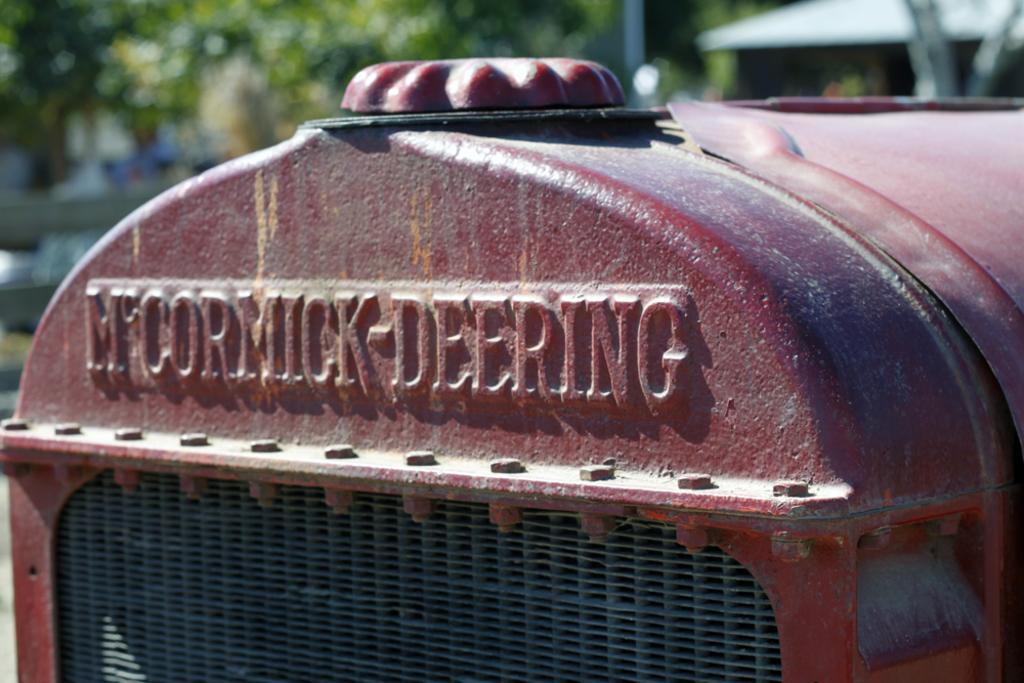Could you give a brief overview of what you see in this image? In this image we can see one big red object looks like a vehicle, one shed, one pole, some trees, some objects in the background, some grass on the ground and the background is blurred. 